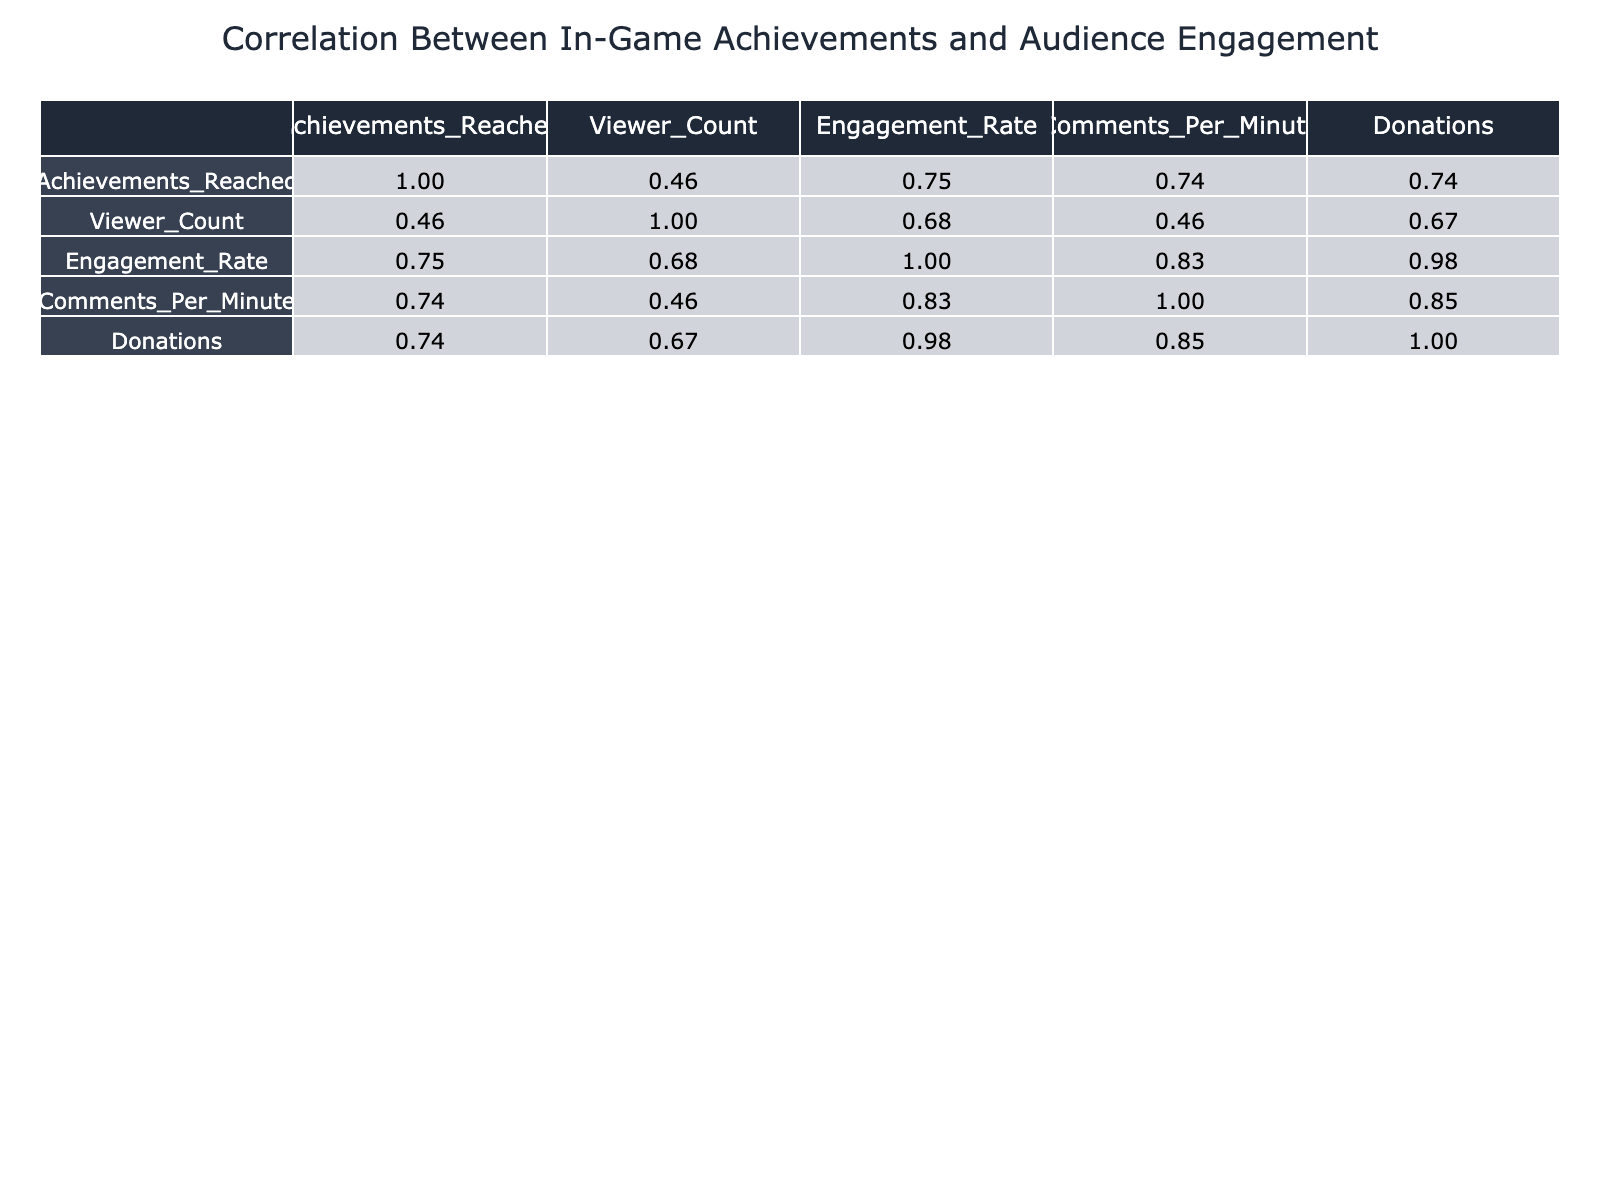What is the highest Engagement Rate among the streamers? The highest Engagement Rate can be found by looking at the Engagement Rate column in the correlation table. Comparing all the values, I find that HeroicSam has the highest Engagement Rate of 0.50.
Answer: 0.50 Which streamer had the lowest Viewer Count and what was it? Examining the Viewer Count column, I can see that the lowest Viewer Count is associated with StreamKing, who had 800 viewers during their streams.
Answer: StreamKing, 800 What is the correlation between Achievements Reached and Donations? To find the correlation, I can look at the correlation table and find the respective values. The correlation between Achievements Reached and Donations is 0.87, indicating a strong positive correlation.
Answer: 0.87 Which game had the highest number of Achievements Reached? I need to compare the Achievements Reached across all the games listed in the table. VortexGamer, who played Minecraft, achieved the highest with 95 Achievements Reached.
Answer: Minecraft, 95 Is there a direct correlation between Viewer Count and Comments Per Minute? I can check the table for the correlation value between Viewer Count and Comments Per Minute. The correlation is 0.85, suggesting a strong positive relationship between these two metrics.
Answer: Yes, 0.85 How does the average Engagement Rate of streamers who played League of Legends and Dota 2 compare to those who played Fortnite and Apex Legends? To find this, I'll first calculate the average Engagement Rate for each group. League of Legends has an Engagement Rate of 0.40, and Dota 2 has 0.45, giving an average of (0.40 + 0.45) / 2 = 0.425. For Fortnite (0.35) and Apex Legends (0.30), the average is (0.35 + 0.30) / 2 = 0.325. Comparing both averages, 0.425 is greater than 0.325.
Answer: League of Legends and Dota 2 average is higher What is the total number of Achievements Reached across all streamers? I need to sum the Achievements Reached for each streamer. Adding them up gives: 75 + 60 + 85 + 70 + 50 + 90 + 65 + 80 + 70 + 95 =  850.
Answer: 850 How many streamers have an Engagement Rate above 0.35? By reviewing the Engagement Rate column, I observe that the following streamers are above 0.35: GamerQueen, ProGamerX, HeroicSam, MasterTactician, and VortexGamer, totaling 5 streamers fitting this description.
Answer: 5 Is it true that the number of Donations is higher for streamers with a higher Viewer Count? To answer this, I can analyze the correlation value mentioned in the table between Donations and Viewer Count, which is 0.77, indicating that higher Viewer Counts tend to align with higher Donations. Therefore, it is true that there is a positive trend.
Answer: Yes 